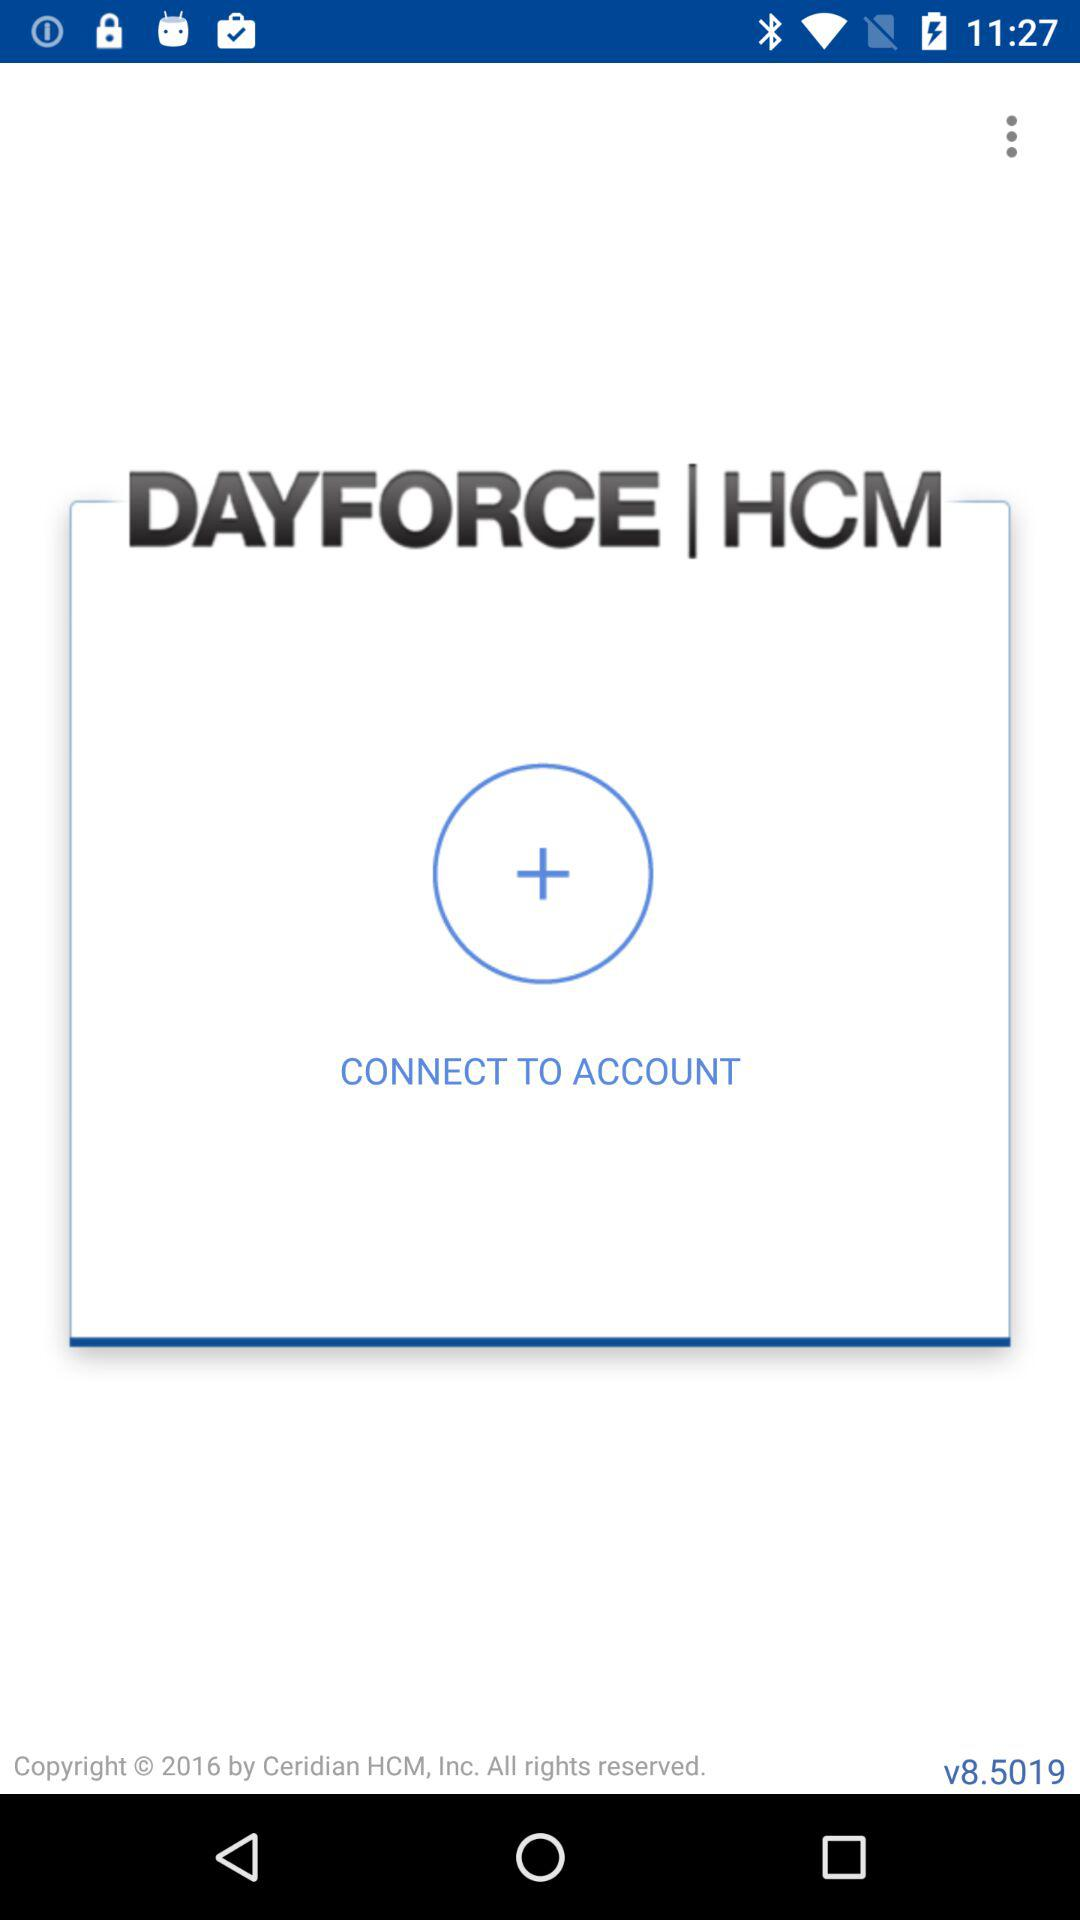What is the application name? The application name is "DAYFORCE | HCM". 